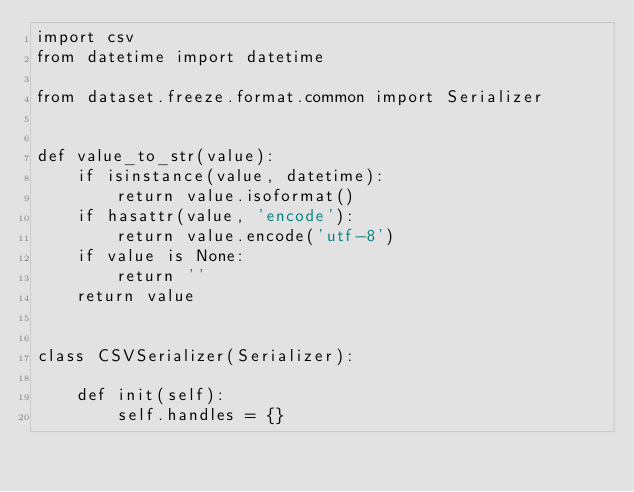Convert code to text. <code><loc_0><loc_0><loc_500><loc_500><_Python_>import csv
from datetime import datetime

from dataset.freeze.format.common import Serializer


def value_to_str(value):
    if isinstance(value, datetime):
        return value.isoformat()
    if hasattr(value, 'encode'):
        return value.encode('utf-8')
    if value is None:
        return ''
    return value


class CSVSerializer(Serializer):

    def init(self):
        self.handles = {}
</code> 